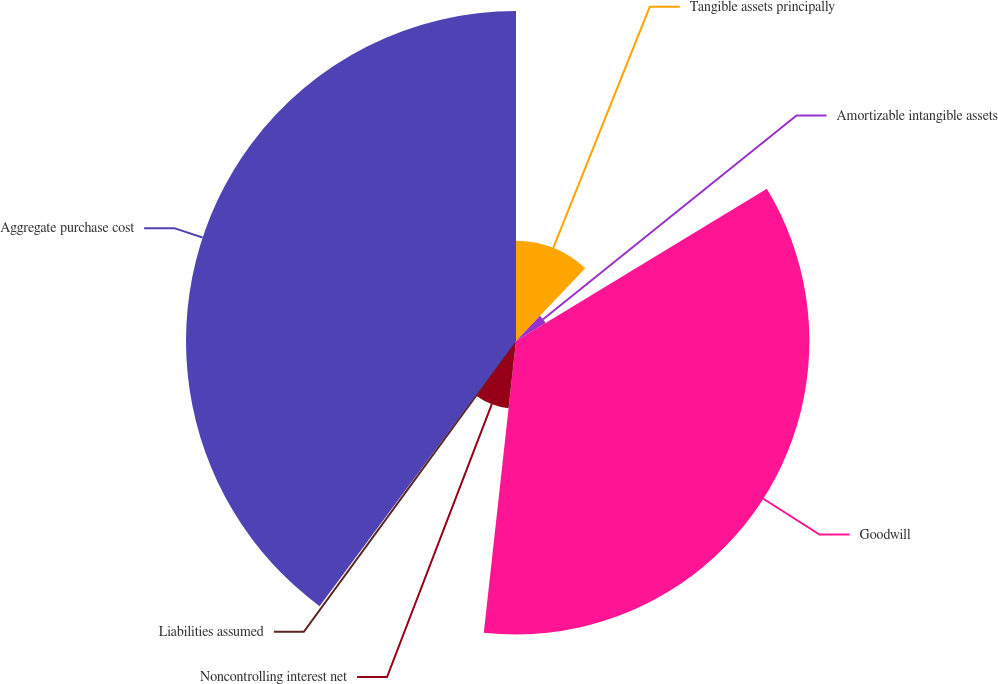Convert chart. <chart><loc_0><loc_0><loc_500><loc_500><pie_chart><fcel>Tangible assets principally<fcel>Amortizable intangible assets<fcel>Goodwill<fcel>Noncontrolling interest net<fcel>Liabilities assumed<fcel>Aggregate purchase cost<nl><fcel>12.12%<fcel>4.2%<fcel>35.43%<fcel>8.16%<fcel>0.24%<fcel>39.85%<nl></chart> 